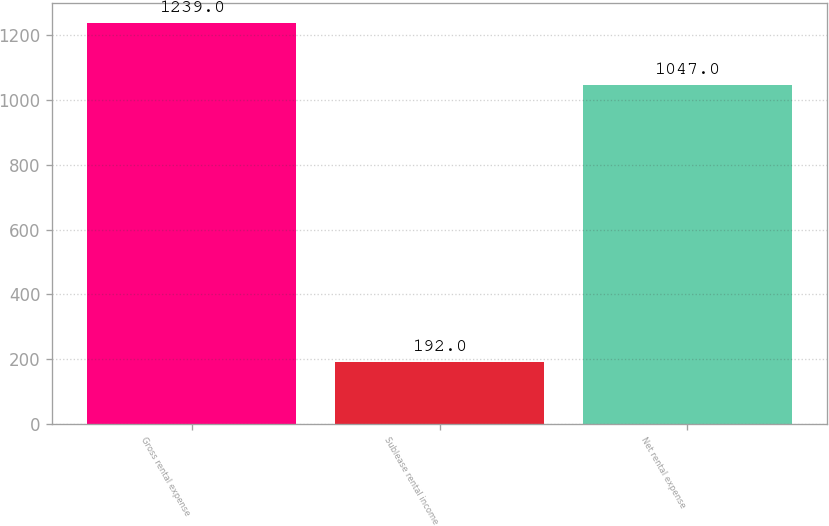Convert chart to OTSL. <chart><loc_0><loc_0><loc_500><loc_500><bar_chart><fcel>Gross rental expense<fcel>Sublease rental income<fcel>Net rental expense<nl><fcel>1239<fcel>192<fcel>1047<nl></chart> 